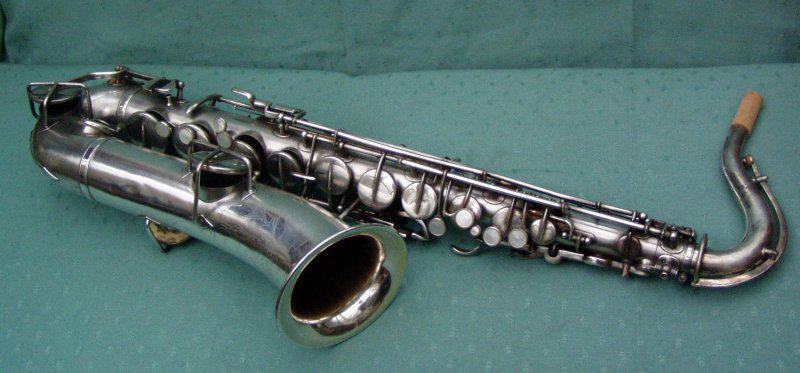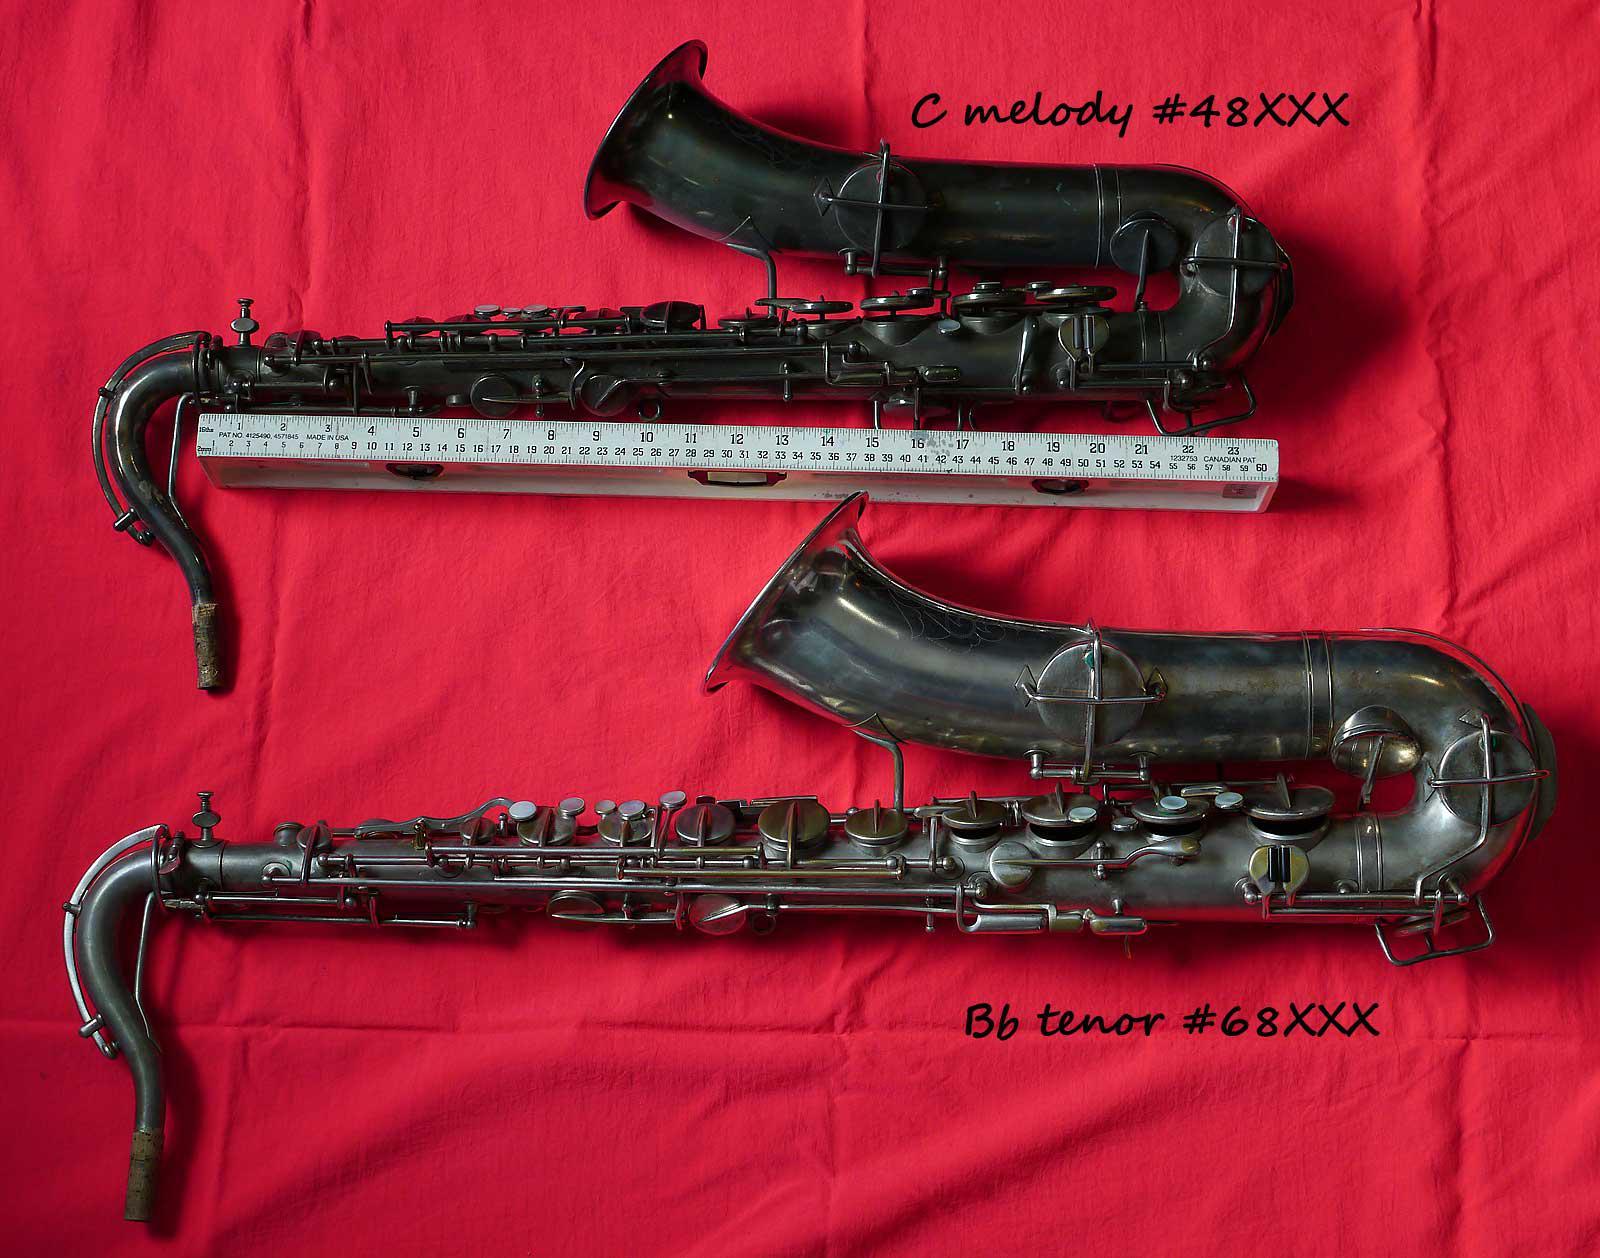The first image is the image on the left, the second image is the image on the right. For the images displayed, is the sentence "The left image shows a saxophone displayed horizontally, with its bell facing downward and its attached mouthpiece facing upward at the right." factually correct? Answer yes or no. Yes. The first image is the image on the left, the second image is the image on the right. Considering the images on both sides, is "The fabric underneath the instruments in one image is red." valid? Answer yes or no. Yes. 